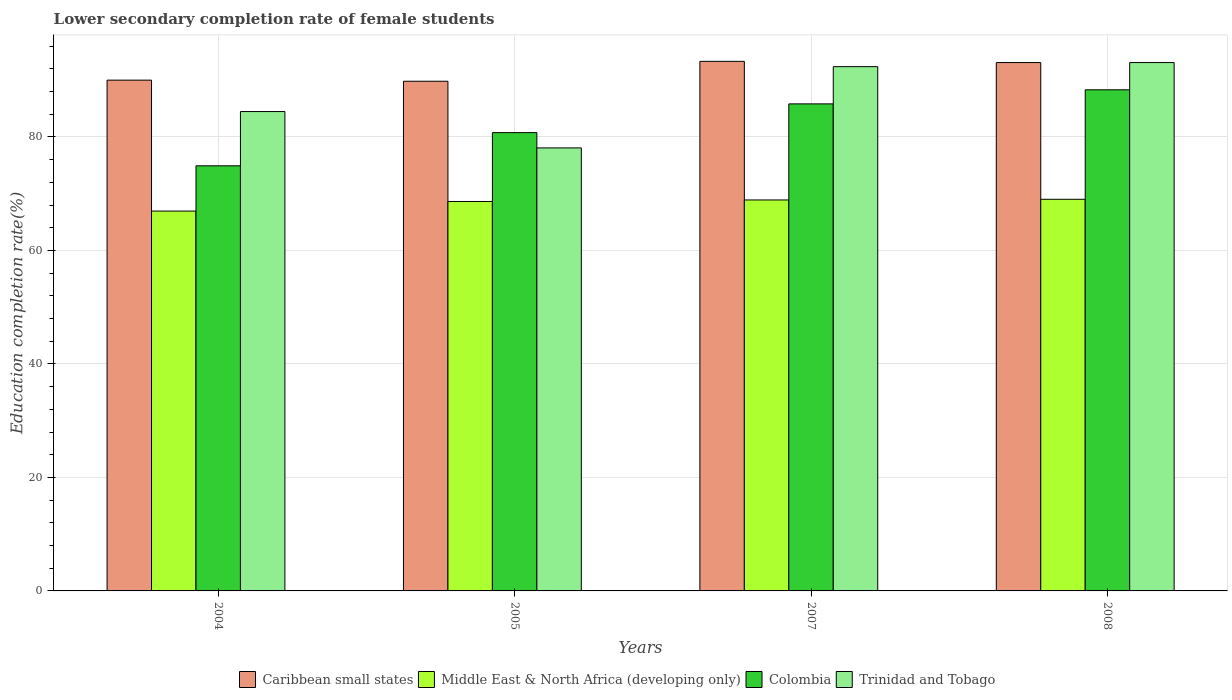How many groups of bars are there?
Give a very brief answer. 4. Are the number of bars per tick equal to the number of legend labels?
Provide a short and direct response. Yes. Are the number of bars on each tick of the X-axis equal?
Provide a succinct answer. Yes. How many bars are there on the 3rd tick from the left?
Your answer should be compact. 4. How many bars are there on the 3rd tick from the right?
Provide a succinct answer. 4. In how many cases, is the number of bars for a given year not equal to the number of legend labels?
Offer a very short reply. 0. What is the lower secondary completion rate of female students in Caribbean small states in 2008?
Your answer should be very brief. 93.1. Across all years, what is the maximum lower secondary completion rate of female students in Trinidad and Tobago?
Provide a short and direct response. 93.1. Across all years, what is the minimum lower secondary completion rate of female students in Caribbean small states?
Ensure brevity in your answer.  89.81. What is the total lower secondary completion rate of female students in Colombia in the graph?
Offer a terse response. 329.79. What is the difference between the lower secondary completion rate of female students in Colombia in 2005 and that in 2007?
Offer a very short reply. -5.06. What is the difference between the lower secondary completion rate of female students in Trinidad and Tobago in 2007 and the lower secondary completion rate of female students in Middle East & North Africa (developing only) in 2005?
Offer a terse response. 23.76. What is the average lower secondary completion rate of female students in Caribbean small states per year?
Your answer should be compact. 91.56. In the year 2005, what is the difference between the lower secondary completion rate of female students in Caribbean small states and lower secondary completion rate of female students in Trinidad and Tobago?
Offer a very short reply. 11.75. In how many years, is the lower secondary completion rate of female students in Trinidad and Tobago greater than 56 %?
Give a very brief answer. 4. What is the ratio of the lower secondary completion rate of female students in Colombia in 2007 to that in 2008?
Offer a terse response. 0.97. Is the difference between the lower secondary completion rate of female students in Caribbean small states in 2005 and 2007 greater than the difference between the lower secondary completion rate of female students in Trinidad and Tobago in 2005 and 2007?
Provide a short and direct response. Yes. What is the difference between the highest and the second highest lower secondary completion rate of female students in Caribbean small states?
Give a very brief answer. 0.21. What is the difference between the highest and the lowest lower secondary completion rate of female students in Trinidad and Tobago?
Offer a terse response. 15.04. In how many years, is the lower secondary completion rate of female students in Caribbean small states greater than the average lower secondary completion rate of female students in Caribbean small states taken over all years?
Ensure brevity in your answer.  2. Is the sum of the lower secondary completion rate of female students in Trinidad and Tobago in 2005 and 2008 greater than the maximum lower secondary completion rate of female students in Caribbean small states across all years?
Provide a succinct answer. Yes. Is it the case that in every year, the sum of the lower secondary completion rate of female students in Colombia and lower secondary completion rate of female students in Caribbean small states is greater than the sum of lower secondary completion rate of female students in Trinidad and Tobago and lower secondary completion rate of female students in Middle East & North Africa (developing only)?
Your response must be concise. No. What does the 1st bar from the left in 2007 represents?
Give a very brief answer. Caribbean small states. Is it the case that in every year, the sum of the lower secondary completion rate of female students in Trinidad and Tobago and lower secondary completion rate of female students in Caribbean small states is greater than the lower secondary completion rate of female students in Colombia?
Provide a short and direct response. Yes. Are all the bars in the graph horizontal?
Your answer should be compact. No. How many years are there in the graph?
Provide a short and direct response. 4. What is the difference between two consecutive major ticks on the Y-axis?
Your answer should be very brief. 20. Does the graph contain any zero values?
Ensure brevity in your answer.  No. Does the graph contain grids?
Offer a very short reply. Yes. Where does the legend appear in the graph?
Ensure brevity in your answer.  Bottom center. How many legend labels are there?
Your response must be concise. 4. What is the title of the graph?
Ensure brevity in your answer.  Lower secondary completion rate of female students. Does "Dominica" appear as one of the legend labels in the graph?
Offer a terse response. No. What is the label or title of the X-axis?
Your response must be concise. Years. What is the label or title of the Y-axis?
Your answer should be very brief. Education completion rate(%). What is the Education completion rate(%) in Caribbean small states in 2004?
Provide a succinct answer. 90. What is the Education completion rate(%) in Middle East & North Africa (developing only) in 2004?
Keep it short and to the point. 66.93. What is the Education completion rate(%) of Colombia in 2004?
Offer a very short reply. 74.91. What is the Education completion rate(%) of Trinidad and Tobago in 2004?
Make the answer very short. 84.47. What is the Education completion rate(%) of Caribbean small states in 2005?
Keep it short and to the point. 89.81. What is the Education completion rate(%) in Middle East & North Africa (developing only) in 2005?
Make the answer very short. 68.62. What is the Education completion rate(%) in Colombia in 2005?
Offer a very short reply. 80.76. What is the Education completion rate(%) in Trinidad and Tobago in 2005?
Provide a succinct answer. 78.06. What is the Education completion rate(%) in Caribbean small states in 2007?
Your answer should be very brief. 93.32. What is the Education completion rate(%) of Middle East & North Africa (developing only) in 2007?
Your answer should be very brief. 68.89. What is the Education completion rate(%) in Colombia in 2007?
Provide a succinct answer. 85.82. What is the Education completion rate(%) of Trinidad and Tobago in 2007?
Your answer should be compact. 92.38. What is the Education completion rate(%) in Caribbean small states in 2008?
Your answer should be compact. 93.1. What is the Education completion rate(%) in Middle East & North Africa (developing only) in 2008?
Offer a very short reply. 69.01. What is the Education completion rate(%) of Colombia in 2008?
Make the answer very short. 88.3. What is the Education completion rate(%) in Trinidad and Tobago in 2008?
Make the answer very short. 93.1. Across all years, what is the maximum Education completion rate(%) of Caribbean small states?
Ensure brevity in your answer.  93.32. Across all years, what is the maximum Education completion rate(%) in Middle East & North Africa (developing only)?
Your response must be concise. 69.01. Across all years, what is the maximum Education completion rate(%) in Colombia?
Provide a succinct answer. 88.3. Across all years, what is the maximum Education completion rate(%) in Trinidad and Tobago?
Provide a succinct answer. 93.1. Across all years, what is the minimum Education completion rate(%) in Caribbean small states?
Ensure brevity in your answer.  89.81. Across all years, what is the minimum Education completion rate(%) of Middle East & North Africa (developing only)?
Your answer should be compact. 66.93. Across all years, what is the minimum Education completion rate(%) in Colombia?
Your response must be concise. 74.91. Across all years, what is the minimum Education completion rate(%) in Trinidad and Tobago?
Ensure brevity in your answer.  78.06. What is the total Education completion rate(%) in Caribbean small states in the graph?
Your answer should be compact. 366.24. What is the total Education completion rate(%) in Middle East & North Africa (developing only) in the graph?
Give a very brief answer. 273.46. What is the total Education completion rate(%) in Colombia in the graph?
Ensure brevity in your answer.  329.79. What is the total Education completion rate(%) of Trinidad and Tobago in the graph?
Your answer should be very brief. 348.02. What is the difference between the Education completion rate(%) in Caribbean small states in 2004 and that in 2005?
Offer a terse response. 0.19. What is the difference between the Education completion rate(%) of Middle East & North Africa (developing only) in 2004 and that in 2005?
Offer a terse response. -1.69. What is the difference between the Education completion rate(%) in Colombia in 2004 and that in 2005?
Offer a very short reply. -5.85. What is the difference between the Education completion rate(%) in Trinidad and Tobago in 2004 and that in 2005?
Your answer should be very brief. 6.41. What is the difference between the Education completion rate(%) of Caribbean small states in 2004 and that in 2007?
Keep it short and to the point. -3.31. What is the difference between the Education completion rate(%) in Middle East & North Africa (developing only) in 2004 and that in 2007?
Your answer should be very brief. -1.96. What is the difference between the Education completion rate(%) in Colombia in 2004 and that in 2007?
Provide a short and direct response. -10.91. What is the difference between the Education completion rate(%) of Trinidad and Tobago in 2004 and that in 2007?
Offer a terse response. -7.91. What is the difference between the Education completion rate(%) in Caribbean small states in 2004 and that in 2008?
Provide a short and direct response. -3.1. What is the difference between the Education completion rate(%) of Middle East & North Africa (developing only) in 2004 and that in 2008?
Your response must be concise. -2.08. What is the difference between the Education completion rate(%) in Colombia in 2004 and that in 2008?
Make the answer very short. -13.39. What is the difference between the Education completion rate(%) of Trinidad and Tobago in 2004 and that in 2008?
Provide a short and direct response. -8.63. What is the difference between the Education completion rate(%) of Caribbean small states in 2005 and that in 2007?
Your answer should be very brief. -3.5. What is the difference between the Education completion rate(%) in Middle East & North Africa (developing only) in 2005 and that in 2007?
Give a very brief answer. -0.27. What is the difference between the Education completion rate(%) in Colombia in 2005 and that in 2007?
Offer a very short reply. -5.06. What is the difference between the Education completion rate(%) of Trinidad and Tobago in 2005 and that in 2007?
Offer a very short reply. -14.32. What is the difference between the Education completion rate(%) in Caribbean small states in 2005 and that in 2008?
Keep it short and to the point. -3.29. What is the difference between the Education completion rate(%) in Middle East & North Africa (developing only) in 2005 and that in 2008?
Ensure brevity in your answer.  -0.39. What is the difference between the Education completion rate(%) in Colombia in 2005 and that in 2008?
Give a very brief answer. -7.55. What is the difference between the Education completion rate(%) of Trinidad and Tobago in 2005 and that in 2008?
Your answer should be compact. -15.04. What is the difference between the Education completion rate(%) of Caribbean small states in 2007 and that in 2008?
Provide a succinct answer. 0.21. What is the difference between the Education completion rate(%) in Middle East & North Africa (developing only) in 2007 and that in 2008?
Keep it short and to the point. -0.12. What is the difference between the Education completion rate(%) in Colombia in 2007 and that in 2008?
Your answer should be very brief. -2.48. What is the difference between the Education completion rate(%) of Trinidad and Tobago in 2007 and that in 2008?
Ensure brevity in your answer.  -0.72. What is the difference between the Education completion rate(%) in Caribbean small states in 2004 and the Education completion rate(%) in Middle East & North Africa (developing only) in 2005?
Keep it short and to the point. 21.38. What is the difference between the Education completion rate(%) of Caribbean small states in 2004 and the Education completion rate(%) of Colombia in 2005?
Your response must be concise. 9.25. What is the difference between the Education completion rate(%) of Caribbean small states in 2004 and the Education completion rate(%) of Trinidad and Tobago in 2005?
Ensure brevity in your answer.  11.94. What is the difference between the Education completion rate(%) in Middle East & North Africa (developing only) in 2004 and the Education completion rate(%) in Colombia in 2005?
Give a very brief answer. -13.82. What is the difference between the Education completion rate(%) in Middle East & North Africa (developing only) in 2004 and the Education completion rate(%) in Trinidad and Tobago in 2005?
Offer a terse response. -11.13. What is the difference between the Education completion rate(%) in Colombia in 2004 and the Education completion rate(%) in Trinidad and Tobago in 2005?
Provide a succinct answer. -3.15. What is the difference between the Education completion rate(%) in Caribbean small states in 2004 and the Education completion rate(%) in Middle East & North Africa (developing only) in 2007?
Your answer should be very brief. 21.11. What is the difference between the Education completion rate(%) of Caribbean small states in 2004 and the Education completion rate(%) of Colombia in 2007?
Provide a succinct answer. 4.18. What is the difference between the Education completion rate(%) in Caribbean small states in 2004 and the Education completion rate(%) in Trinidad and Tobago in 2007?
Give a very brief answer. -2.38. What is the difference between the Education completion rate(%) in Middle East & North Africa (developing only) in 2004 and the Education completion rate(%) in Colombia in 2007?
Keep it short and to the point. -18.89. What is the difference between the Education completion rate(%) in Middle East & North Africa (developing only) in 2004 and the Education completion rate(%) in Trinidad and Tobago in 2007?
Your answer should be compact. -25.45. What is the difference between the Education completion rate(%) in Colombia in 2004 and the Education completion rate(%) in Trinidad and Tobago in 2007?
Ensure brevity in your answer.  -17.47. What is the difference between the Education completion rate(%) of Caribbean small states in 2004 and the Education completion rate(%) of Middle East & North Africa (developing only) in 2008?
Give a very brief answer. 20.99. What is the difference between the Education completion rate(%) in Caribbean small states in 2004 and the Education completion rate(%) in Colombia in 2008?
Your response must be concise. 1.7. What is the difference between the Education completion rate(%) of Caribbean small states in 2004 and the Education completion rate(%) of Trinidad and Tobago in 2008?
Your answer should be compact. -3.1. What is the difference between the Education completion rate(%) of Middle East & North Africa (developing only) in 2004 and the Education completion rate(%) of Colombia in 2008?
Your answer should be very brief. -21.37. What is the difference between the Education completion rate(%) of Middle East & North Africa (developing only) in 2004 and the Education completion rate(%) of Trinidad and Tobago in 2008?
Give a very brief answer. -26.17. What is the difference between the Education completion rate(%) of Colombia in 2004 and the Education completion rate(%) of Trinidad and Tobago in 2008?
Offer a very short reply. -18.19. What is the difference between the Education completion rate(%) in Caribbean small states in 2005 and the Education completion rate(%) in Middle East & North Africa (developing only) in 2007?
Keep it short and to the point. 20.92. What is the difference between the Education completion rate(%) of Caribbean small states in 2005 and the Education completion rate(%) of Colombia in 2007?
Offer a terse response. 3.99. What is the difference between the Education completion rate(%) in Caribbean small states in 2005 and the Education completion rate(%) in Trinidad and Tobago in 2007?
Ensure brevity in your answer.  -2.57. What is the difference between the Education completion rate(%) in Middle East & North Africa (developing only) in 2005 and the Education completion rate(%) in Colombia in 2007?
Keep it short and to the point. -17.2. What is the difference between the Education completion rate(%) of Middle East & North Africa (developing only) in 2005 and the Education completion rate(%) of Trinidad and Tobago in 2007?
Make the answer very short. -23.76. What is the difference between the Education completion rate(%) of Colombia in 2005 and the Education completion rate(%) of Trinidad and Tobago in 2007?
Offer a terse response. -11.63. What is the difference between the Education completion rate(%) in Caribbean small states in 2005 and the Education completion rate(%) in Middle East & North Africa (developing only) in 2008?
Give a very brief answer. 20.8. What is the difference between the Education completion rate(%) in Caribbean small states in 2005 and the Education completion rate(%) in Colombia in 2008?
Ensure brevity in your answer.  1.51. What is the difference between the Education completion rate(%) of Caribbean small states in 2005 and the Education completion rate(%) of Trinidad and Tobago in 2008?
Keep it short and to the point. -3.29. What is the difference between the Education completion rate(%) in Middle East & North Africa (developing only) in 2005 and the Education completion rate(%) in Colombia in 2008?
Offer a terse response. -19.68. What is the difference between the Education completion rate(%) of Middle East & North Africa (developing only) in 2005 and the Education completion rate(%) of Trinidad and Tobago in 2008?
Your answer should be compact. -24.48. What is the difference between the Education completion rate(%) in Colombia in 2005 and the Education completion rate(%) in Trinidad and Tobago in 2008?
Offer a very short reply. -12.35. What is the difference between the Education completion rate(%) in Caribbean small states in 2007 and the Education completion rate(%) in Middle East & North Africa (developing only) in 2008?
Ensure brevity in your answer.  24.31. What is the difference between the Education completion rate(%) of Caribbean small states in 2007 and the Education completion rate(%) of Colombia in 2008?
Give a very brief answer. 5.01. What is the difference between the Education completion rate(%) of Caribbean small states in 2007 and the Education completion rate(%) of Trinidad and Tobago in 2008?
Your response must be concise. 0.21. What is the difference between the Education completion rate(%) in Middle East & North Africa (developing only) in 2007 and the Education completion rate(%) in Colombia in 2008?
Your answer should be compact. -19.41. What is the difference between the Education completion rate(%) in Middle East & North Africa (developing only) in 2007 and the Education completion rate(%) in Trinidad and Tobago in 2008?
Offer a terse response. -24.21. What is the difference between the Education completion rate(%) of Colombia in 2007 and the Education completion rate(%) of Trinidad and Tobago in 2008?
Provide a short and direct response. -7.28. What is the average Education completion rate(%) of Caribbean small states per year?
Offer a very short reply. 91.56. What is the average Education completion rate(%) in Middle East & North Africa (developing only) per year?
Give a very brief answer. 68.36. What is the average Education completion rate(%) in Colombia per year?
Offer a very short reply. 82.45. What is the average Education completion rate(%) of Trinidad and Tobago per year?
Make the answer very short. 87. In the year 2004, what is the difference between the Education completion rate(%) of Caribbean small states and Education completion rate(%) of Middle East & North Africa (developing only)?
Provide a succinct answer. 23.07. In the year 2004, what is the difference between the Education completion rate(%) in Caribbean small states and Education completion rate(%) in Colombia?
Offer a terse response. 15.1. In the year 2004, what is the difference between the Education completion rate(%) in Caribbean small states and Education completion rate(%) in Trinidad and Tobago?
Keep it short and to the point. 5.53. In the year 2004, what is the difference between the Education completion rate(%) of Middle East & North Africa (developing only) and Education completion rate(%) of Colombia?
Your answer should be compact. -7.97. In the year 2004, what is the difference between the Education completion rate(%) in Middle East & North Africa (developing only) and Education completion rate(%) in Trinidad and Tobago?
Your response must be concise. -17.54. In the year 2004, what is the difference between the Education completion rate(%) in Colombia and Education completion rate(%) in Trinidad and Tobago?
Make the answer very short. -9.56. In the year 2005, what is the difference between the Education completion rate(%) in Caribbean small states and Education completion rate(%) in Middle East & North Africa (developing only)?
Your answer should be very brief. 21.19. In the year 2005, what is the difference between the Education completion rate(%) of Caribbean small states and Education completion rate(%) of Colombia?
Provide a short and direct response. 9.06. In the year 2005, what is the difference between the Education completion rate(%) of Caribbean small states and Education completion rate(%) of Trinidad and Tobago?
Provide a succinct answer. 11.75. In the year 2005, what is the difference between the Education completion rate(%) of Middle East & North Africa (developing only) and Education completion rate(%) of Colombia?
Your response must be concise. -12.14. In the year 2005, what is the difference between the Education completion rate(%) in Middle East & North Africa (developing only) and Education completion rate(%) in Trinidad and Tobago?
Keep it short and to the point. -9.44. In the year 2005, what is the difference between the Education completion rate(%) of Colombia and Education completion rate(%) of Trinidad and Tobago?
Provide a succinct answer. 2.69. In the year 2007, what is the difference between the Education completion rate(%) in Caribbean small states and Education completion rate(%) in Middle East & North Africa (developing only)?
Your answer should be compact. 24.43. In the year 2007, what is the difference between the Education completion rate(%) in Caribbean small states and Education completion rate(%) in Colombia?
Keep it short and to the point. 7.5. In the year 2007, what is the difference between the Education completion rate(%) of Caribbean small states and Education completion rate(%) of Trinidad and Tobago?
Offer a very short reply. 0.93. In the year 2007, what is the difference between the Education completion rate(%) in Middle East & North Africa (developing only) and Education completion rate(%) in Colombia?
Ensure brevity in your answer.  -16.93. In the year 2007, what is the difference between the Education completion rate(%) of Middle East & North Africa (developing only) and Education completion rate(%) of Trinidad and Tobago?
Keep it short and to the point. -23.49. In the year 2007, what is the difference between the Education completion rate(%) in Colombia and Education completion rate(%) in Trinidad and Tobago?
Offer a terse response. -6.56. In the year 2008, what is the difference between the Education completion rate(%) in Caribbean small states and Education completion rate(%) in Middle East & North Africa (developing only)?
Make the answer very short. 24.09. In the year 2008, what is the difference between the Education completion rate(%) of Caribbean small states and Education completion rate(%) of Colombia?
Ensure brevity in your answer.  4.8. In the year 2008, what is the difference between the Education completion rate(%) in Caribbean small states and Education completion rate(%) in Trinidad and Tobago?
Your answer should be compact. 0. In the year 2008, what is the difference between the Education completion rate(%) of Middle East & North Africa (developing only) and Education completion rate(%) of Colombia?
Provide a short and direct response. -19.29. In the year 2008, what is the difference between the Education completion rate(%) in Middle East & North Africa (developing only) and Education completion rate(%) in Trinidad and Tobago?
Your answer should be very brief. -24.09. In the year 2008, what is the difference between the Education completion rate(%) in Colombia and Education completion rate(%) in Trinidad and Tobago?
Your response must be concise. -4.8. What is the ratio of the Education completion rate(%) of Caribbean small states in 2004 to that in 2005?
Your answer should be compact. 1. What is the ratio of the Education completion rate(%) of Middle East & North Africa (developing only) in 2004 to that in 2005?
Make the answer very short. 0.98. What is the ratio of the Education completion rate(%) in Colombia in 2004 to that in 2005?
Your answer should be very brief. 0.93. What is the ratio of the Education completion rate(%) in Trinidad and Tobago in 2004 to that in 2005?
Provide a short and direct response. 1.08. What is the ratio of the Education completion rate(%) in Caribbean small states in 2004 to that in 2007?
Provide a succinct answer. 0.96. What is the ratio of the Education completion rate(%) in Middle East & North Africa (developing only) in 2004 to that in 2007?
Give a very brief answer. 0.97. What is the ratio of the Education completion rate(%) of Colombia in 2004 to that in 2007?
Your answer should be compact. 0.87. What is the ratio of the Education completion rate(%) of Trinidad and Tobago in 2004 to that in 2007?
Your answer should be very brief. 0.91. What is the ratio of the Education completion rate(%) of Caribbean small states in 2004 to that in 2008?
Ensure brevity in your answer.  0.97. What is the ratio of the Education completion rate(%) of Middle East & North Africa (developing only) in 2004 to that in 2008?
Give a very brief answer. 0.97. What is the ratio of the Education completion rate(%) in Colombia in 2004 to that in 2008?
Provide a succinct answer. 0.85. What is the ratio of the Education completion rate(%) of Trinidad and Tobago in 2004 to that in 2008?
Give a very brief answer. 0.91. What is the ratio of the Education completion rate(%) in Caribbean small states in 2005 to that in 2007?
Your response must be concise. 0.96. What is the ratio of the Education completion rate(%) in Middle East & North Africa (developing only) in 2005 to that in 2007?
Make the answer very short. 1. What is the ratio of the Education completion rate(%) of Colombia in 2005 to that in 2007?
Keep it short and to the point. 0.94. What is the ratio of the Education completion rate(%) in Trinidad and Tobago in 2005 to that in 2007?
Ensure brevity in your answer.  0.84. What is the ratio of the Education completion rate(%) in Caribbean small states in 2005 to that in 2008?
Offer a very short reply. 0.96. What is the ratio of the Education completion rate(%) of Colombia in 2005 to that in 2008?
Your response must be concise. 0.91. What is the ratio of the Education completion rate(%) of Trinidad and Tobago in 2005 to that in 2008?
Your answer should be compact. 0.84. What is the ratio of the Education completion rate(%) of Caribbean small states in 2007 to that in 2008?
Provide a short and direct response. 1. What is the ratio of the Education completion rate(%) in Middle East & North Africa (developing only) in 2007 to that in 2008?
Provide a succinct answer. 1. What is the ratio of the Education completion rate(%) in Colombia in 2007 to that in 2008?
Provide a succinct answer. 0.97. What is the ratio of the Education completion rate(%) of Trinidad and Tobago in 2007 to that in 2008?
Your answer should be very brief. 0.99. What is the difference between the highest and the second highest Education completion rate(%) in Caribbean small states?
Offer a terse response. 0.21. What is the difference between the highest and the second highest Education completion rate(%) in Middle East & North Africa (developing only)?
Your response must be concise. 0.12. What is the difference between the highest and the second highest Education completion rate(%) in Colombia?
Your answer should be compact. 2.48. What is the difference between the highest and the second highest Education completion rate(%) in Trinidad and Tobago?
Ensure brevity in your answer.  0.72. What is the difference between the highest and the lowest Education completion rate(%) in Caribbean small states?
Give a very brief answer. 3.5. What is the difference between the highest and the lowest Education completion rate(%) in Middle East & North Africa (developing only)?
Offer a very short reply. 2.08. What is the difference between the highest and the lowest Education completion rate(%) in Colombia?
Your answer should be very brief. 13.39. What is the difference between the highest and the lowest Education completion rate(%) in Trinidad and Tobago?
Provide a succinct answer. 15.04. 